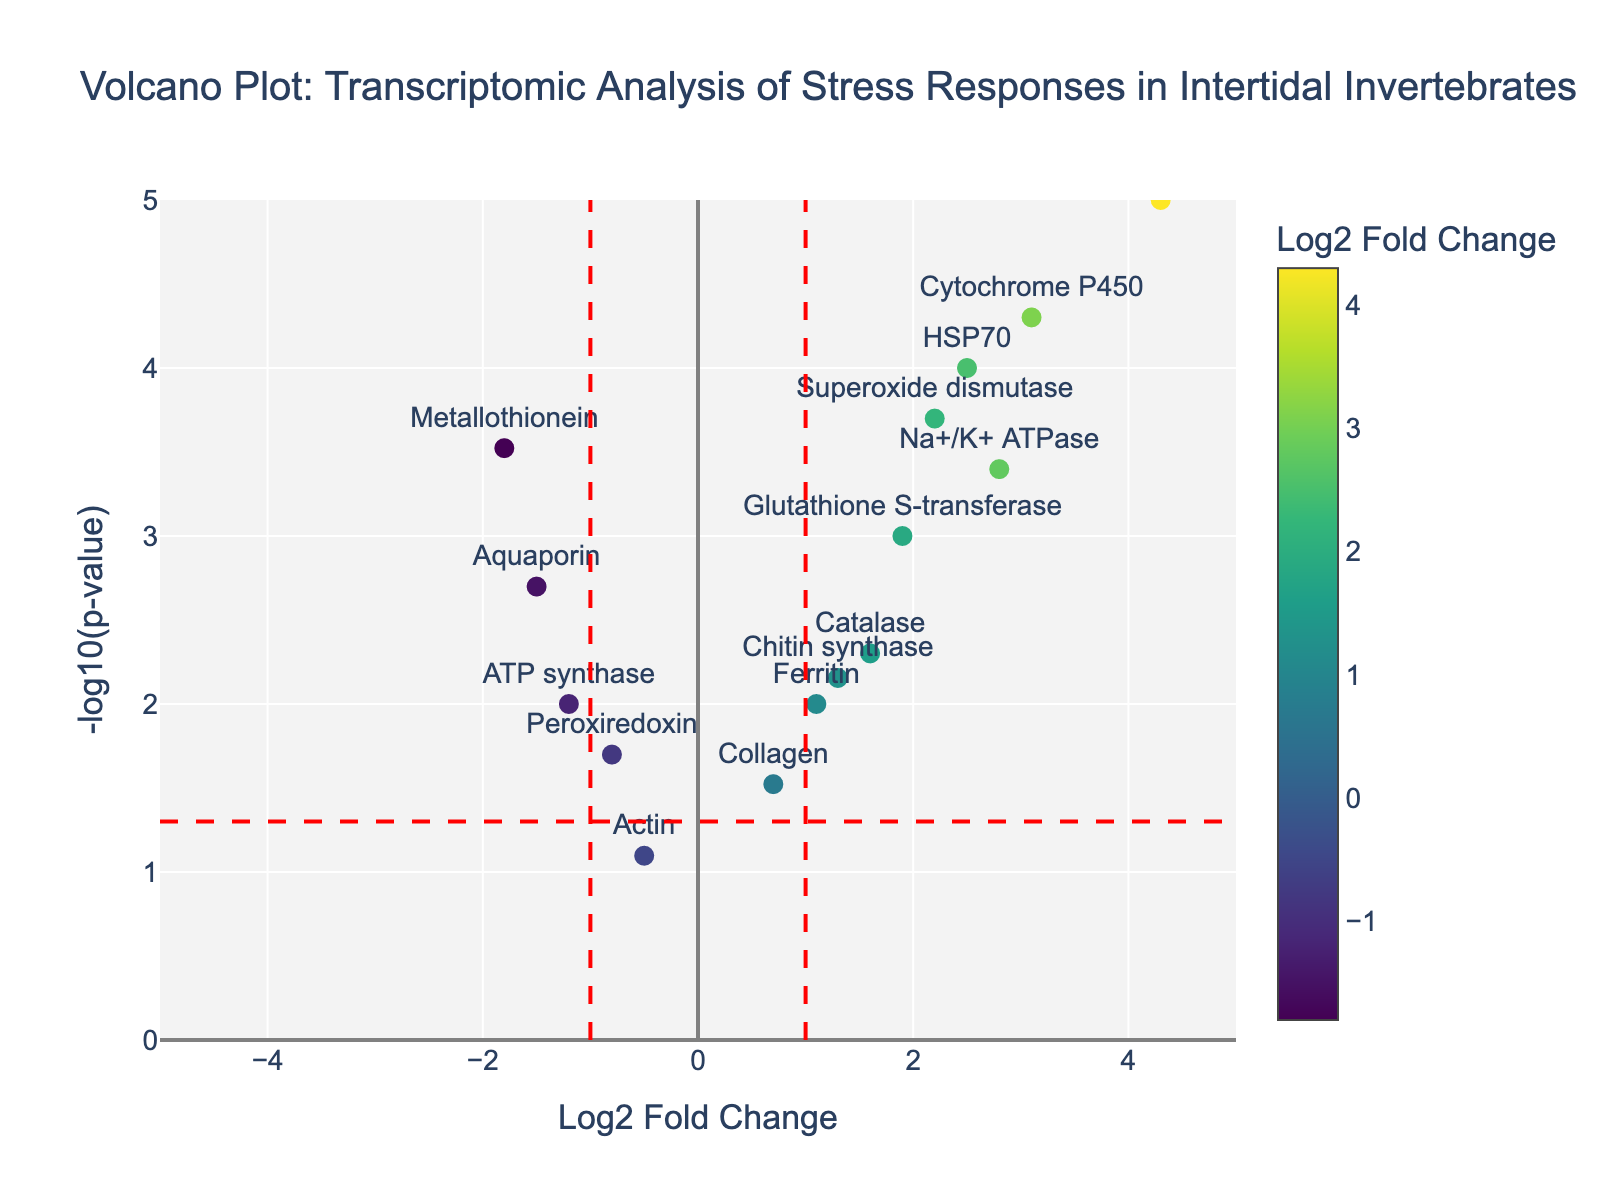Which gene shows the highest Log2 Fold Change? To find the gene with the highest Log2 Fold Change, look at the x-axis values. The gene farthest to the right will have the highest Log2 fold change.
Answer: Vitellogenin Which gene shows the lowest p-value? The y-axis represents -log10(p-value), so the gene with the highest y-axis value has the lowest p-value.
Answer: Vitellogenin Which genes have a Log2 Fold Change greater than 1 and a -log10(p-value) greater than 2? To answer this, identify dots on the volcano plot that are positioned to the right of the vertical line at Log2 Fold Change = 1 and above the horizontal line at -log10(p-value) = 2.
Answer: HSP70, Cytochrome P450, Superoxide dismutase, Na+/K+ ATPase, Vitellogenin How many genes have a fold change less than -1? Count the genes positioned to the left side of the vertical line at Log2 Fold Change = -1.
Answer: 3 Which gene has the highest -log10(p-value) among those with negative Log2 Fold Change? Locate the genes on the left side of the vertical line at Log2 Fold Change = 0 and identify the one with the highest y-axis position (maximum -log10(p-value)).
Answer: Metallothionein How many genes have a statistically significant p-value (below 0.05) but a Log2 Fold Change between -1 and 1? Count the number of genes that lie above the horizontal line at -log10(p-value) = 1.3 and between the vertical lines at Log2 Fold Change = -1 and 1.
Answer: 4 Which gene has a Log2 Fold Change closest to zero but still statistically significant (p-value < 0.05)? Look for the gene closest to the y-axis (Log2 Fold Change = 0) but above the horizontal line at -log10(p-value) = 1.3.
Answer: Peroxiredoxin Which genes are up-regulated with a Log2 Fold Change greater than 1 and have p-values indicating significant expression changes (p-value < 0.01)? Find the genes on the right side of the vertical line at Log2 Fold Change = 1 and above the horizontal line at -log10(p-value) ≈ 2. These genes are statistically significant and up-regulated.
Answer: HSP70, Cytochrome P450, Superoxide dismutase, Na+/K+ ATPase, Vitellogenin Which two genes have the closest Log2 Fold Change values but differ greatly in p-value? Identify pairs of genes with similar x-axis values (Log2 Fold Change) but different y-axis values (-log10(p-value)).
Answer: Aquaporin and ATP synthase What is the p-value of Catalase? Find the point labeled Catalase on the volcano plot and note its y-axis value. Use the y-axis label to convert -log10(p-value) back to p-value. (-log10(p-value) for Catalase is approximately 2.3, hence p-value = 10^-2.3)
Answer: 0.005 